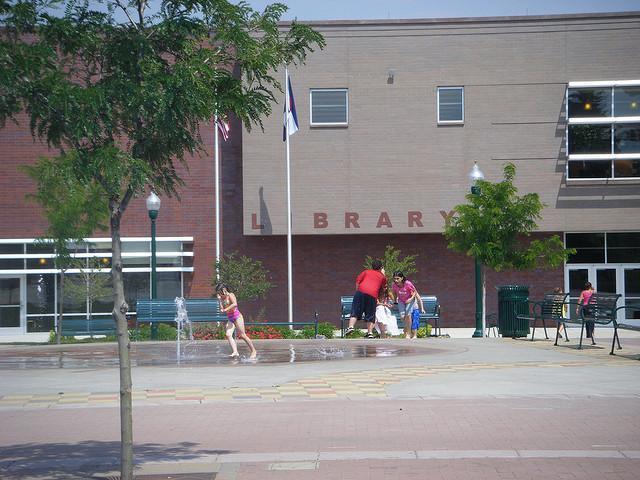How many people are in this picture?
Give a very brief answer. 4. How many black dog in the image?
Give a very brief answer. 0. 